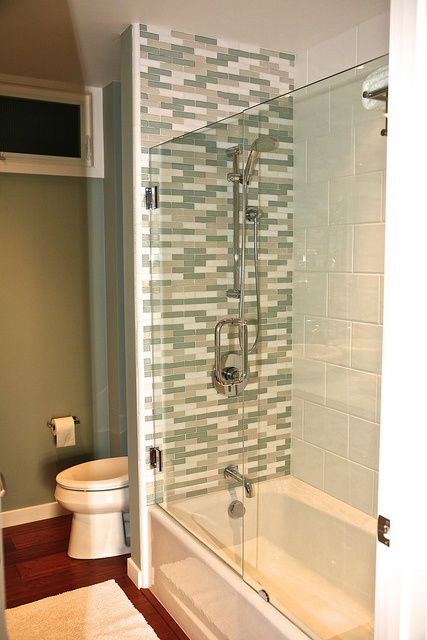Describe the objects in this image and their specific colors. I can see a toilet in black, ivory, and tan tones in this image. 